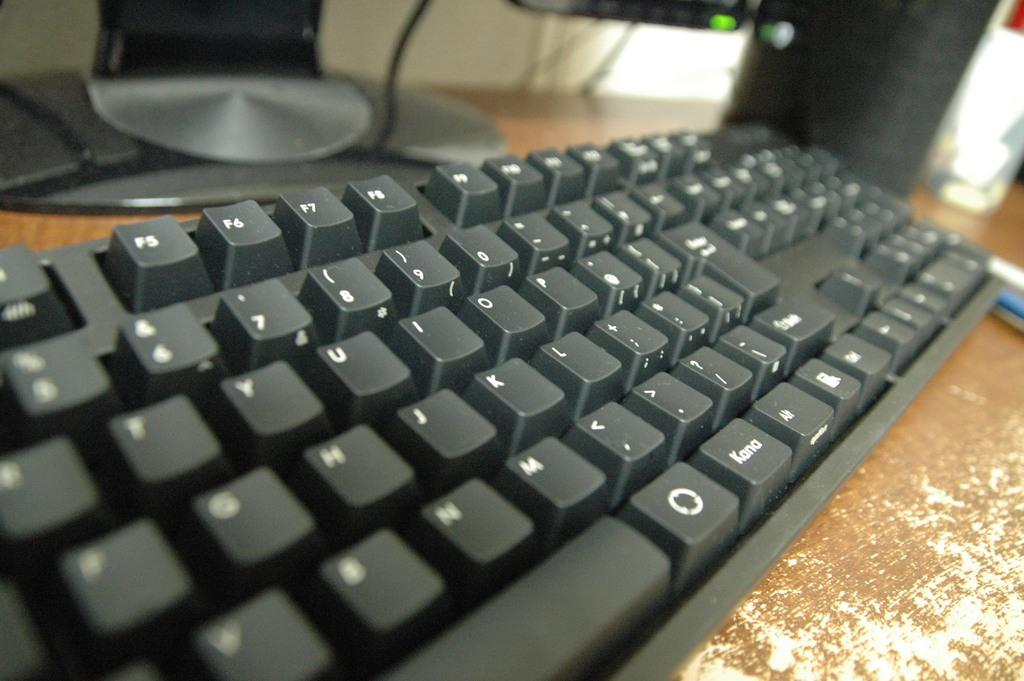<image>
Describe the image concisely. A side angle picture of a keyboard with the word "kana" on it 